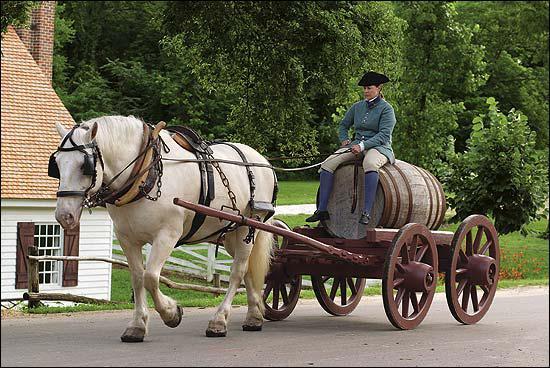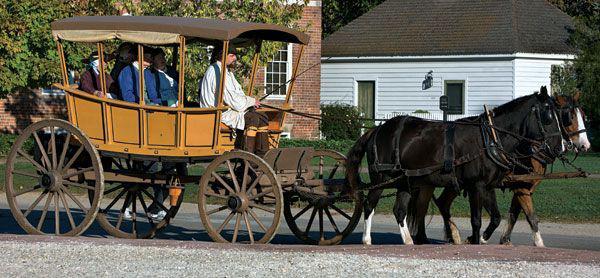The first image is the image on the left, the second image is the image on the right. For the images shown, is this caption "In at least one image there is a single man with a hat on a cart being pulled by at least one mini horse." true? Answer yes or no. No. 